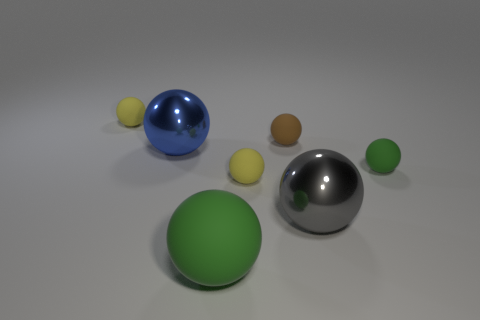Subtract all brown balls. How many balls are left? 6 Subtract all green balls. How many balls are left? 5 Add 1 matte spheres. How many objects exist? 8 Subtract all red balls. Subtract all gray blocks. How many balls are left? 7 Add 1 small green objects. How many small green objects are left? 2 Add 7 tiny green metallic cylinders. How many tiny green metallic cylinders exist? 7 Subtract 0 red cubes. How many objects are left? 7 Subtract all tiny yellow rubber spheres. Subtract all metallic objects. How many objects are left? 3 